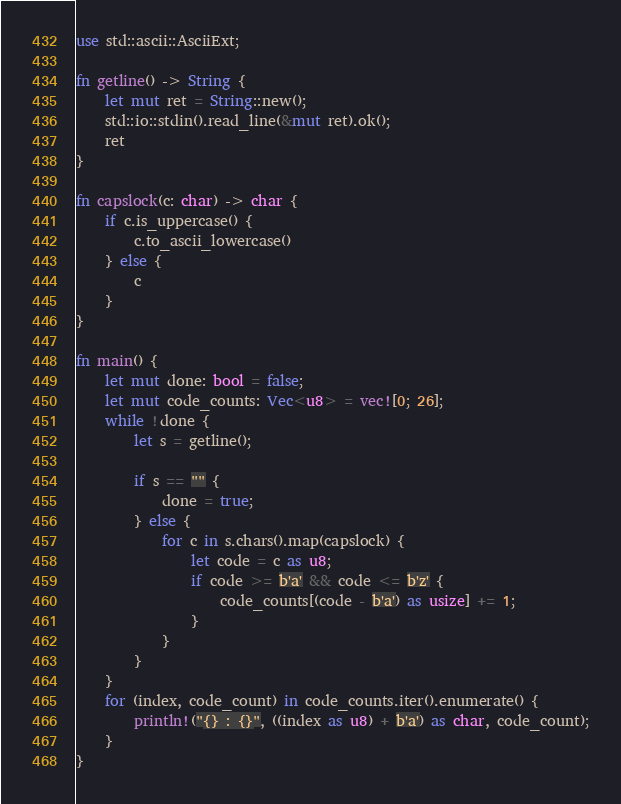Convert code to text. <code><loc_0><loc_0><loc_500><loc_500><_Rust_>use std::ascii::AsciiExt;

fn getline() -> String {
    let mut ret = String::new();
    std::io::stdin().read_line(&mut ret).ok();
    ret
}

fn capslock(c: char) -> char {
    if c.is_uppercase() {
        c.to_ascii_lowercase()
    } else {
        c
    }
}

fn main() {
    let mut done: bool = false;
    let mut code_counts: Vec<u8> = vec![0; 26];
    while !done {
        let s = getline();

        if s == "" {
            done = true;
        } else {
            for c in s.chars().map(capslock) {
                let code = c as u8;
                if code >= b'a' && code <= b'z' {
                    code_counts[(code - b'a') as usize] += 1;
                }
            }
        }
    }
    for (index, code_count) in code_counts.iter().enumerate() {
        println!("{} : {}", ((index as u8) + b'a') as char, code_count);
    }
}

</code> 